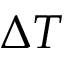<formula> <loc_0><loc_0><loc_500><loc_500>\Delta T</formula> 